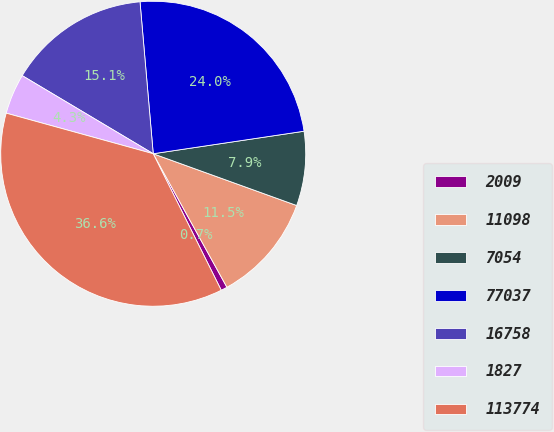<chart> <loc_0><loc_0><loc_500><loc_500><pie_chart><fcel>2009<fcel>11098<fcel>7054<fcel>77037<fcel>16758<fcel>1827<fcel>113774<nl><fcel>0.67%<fcel>11.46%<fcel>7.87%<fcel>24.02%<fcel>15.06%<fcel>4.27%<fcel>36.64%<nl></chart> 